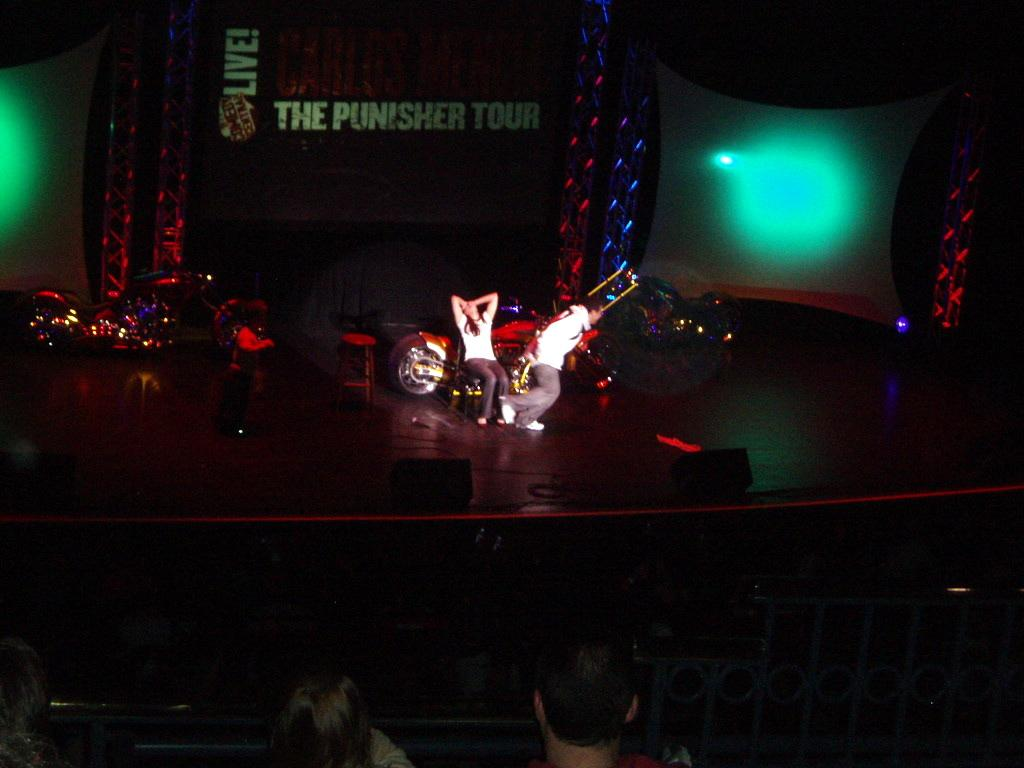What are the two people in the image doing? Two people are performing on a stage. What can be seen behind the performers? There are bikes behind the performers. What is present in the background of the image? There is a screen in the background. Who is watching the performance? There are people watching the show. What type of tomatoes are being used as props in the performance? There are no tomatoes present in the image, and they are not being used as props in the performance. 